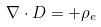<formula> <loc_0><loc_0><loc_500><loc_500>\nabla \cdot D = + \rho _ { e }</formula> 